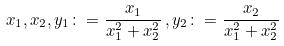Convert formula to latex. <formula><loc_0><loc_0><loc_500><loc_500>x _ { 1 } , x _ { 2 } , y _ { 1 } \colon = \frac { x _ { 1 } } { x _ { 1 } ^ { 2 } + x _ { 2 } ^ { 2 } } \, , y _ { 2 } \colon = \frac { x _ { 2 } } { x _ { 1 } ^ { 2 } + x _ { 2 } ^ { 2 } }</formula> 